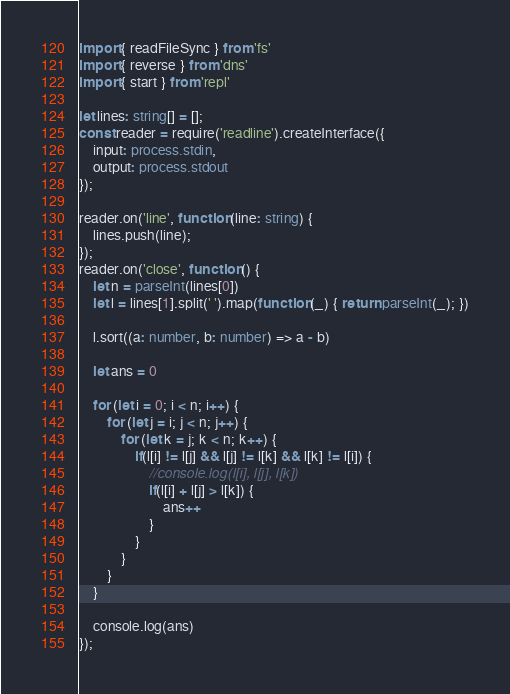Convert code to text. <code><loc_0><loc_0><loc_500><loc_500><_TypeScript_>import { readFileSync } from 'fs'
import { reverse } from 'dns'
import { start } from 'repl'
 
let lines: string[] = [];
const reader = require('readline').createInterface({
    input: process.stdin,
    output: process.stdout
});
 
reader.on('line', function (line: string) {
    lines.push(line);
});
reader.on('close', function () {
    let n = parseInt(lines[0])
    let l = lines[1].split(' ').map(function (_) { return parseInt(_); })

    l.sort((a: number, b: number) => a - b)

    let ans = 0

    for (let i = 0; i < n; i++) {
        for (let j = i; j < n; j++) {
            for (let k = j; k < n; k++) {
                if(l[i] != l[j] && l[j] != l[k] && l[k] != l[i]) {
                    //console.log(l[i], l[j], l[k])
                    if(l[i] + l[j] > l[k]) {
                        ans++
                    }
                }
            }
        }   
    }
    
    console.log(ans)
});</code> 